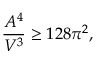Convert formula to latex. <formula><loc_0><loc_0><loc_500><loc_500>\frac { A ^ { 4 } } { V ^ { 3 } } \geq 1 2 8 \pi ^ { 2 } ,</formula> 